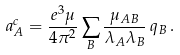Convert formula to latex. <formula><loc_0><loc_0><loc_500><loc_500>a _ { A } ^ { c } = \frac { e ^ { 3 } \mu } { 4 \pi ^ { 2 } } \sum _ { B } \frac { \mu _ { A B } } { \lambda _ { A } \lambda _ { B } } \, q _ { B } \, .</formula> 